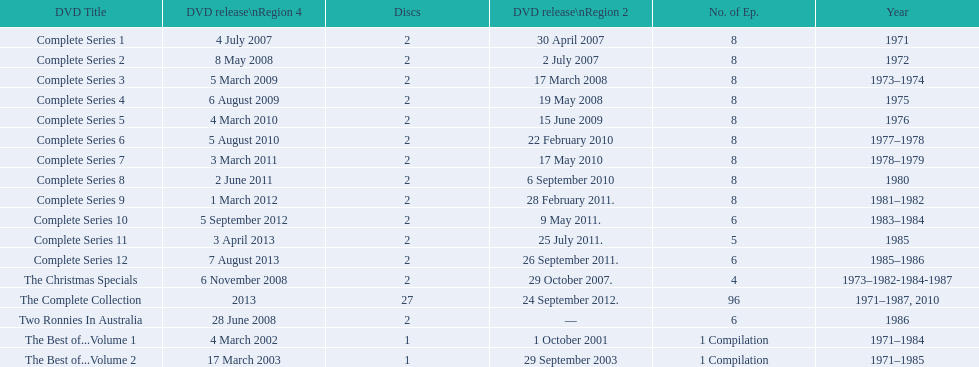How many "best of" volumes compile the top episodes of the television show "the two ronnies". 2. Would you mind parsing the complete table? {'header': ['DVD Title', 'DVD release\\nRegion 4', 'Discs', 'DVD release\\nRegion 2', 'No. of Ep.', 'Year'], 'rows': [['Complete Series 1', '4 July 2007', '2', '30 April 2007', '8', '1971'], ['Complete Series 2', '8 May 2008', '2', '2 July 2007', '8', '1972'], ['Complete Series 3', '5 March 2009', '2', '17 March 2008', '8', '1973–1974'], ['Complete Series 4', '6 August 2009', '2', '19 May 2008', '8', '1975'], ['Complete Series 5', '4 March 2010', '2', '15 June 2009', '8', '1976'], ['Complete Series 6', '5 August 2010', '2', '22 February 2010', '8', '1977–1978'], ['Complete Series 7', '3 March 2011', '2', '17 May 2010', '8', '1978–1979'], ['Complete Series 8', '2 June 2011', '2', '6 September 2010', '8', '1980'], ['Complete Series 9', '1 March 2012', '2', '28 February 2011.', '8', '1981–1982'], ['Complete Series 10', '5 September 2012', '2', '9 May 2011.', '6', '1983–1984'], ['Complete Series 11', '3 April 2013', '2', '25 July 2011.', '5', '1985'], ['Complete Series 12', '7 August 2013', '2', '26 September 2011.', '6', '1985–1986'], ['The Christmas Specials', '6 November 2008', '2', '29 October 2007.', '4', '1973–1982-1984-1987'], ['The Complete Collection', '2013', '27', '24 September 2012.', '96', '1971–1987, 2010'], ['Two Ronnies In Australia', '28 June 2008', '2', '—', '6', '1986'], ['The Best of...Volume 1', '4 March 2002', '1', '1 October 2001', '1 Compilation', '1971–1984'], ['The Best of...Volume 2', '17 March 2003', '1', '29 September 2003', '1 Compilation', '1971–1985']]} 